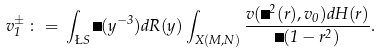Convert formula to latex. <formula><loc_0><loc_0><loc_500><loc_500>v _ { 1 } ^ { \pm } \, \colon = \, \int _ { \L S } \Delta ( y ^ { - 3 } ) d R ( y ) \int _ { X ( M , N ) } \frac { v ( \Delta ^ { 2 } ( r ) , v _ { 0 } ) d H ( r ) } { \Delta ( 1 - r ^ { 2 } ) } .</formula> 